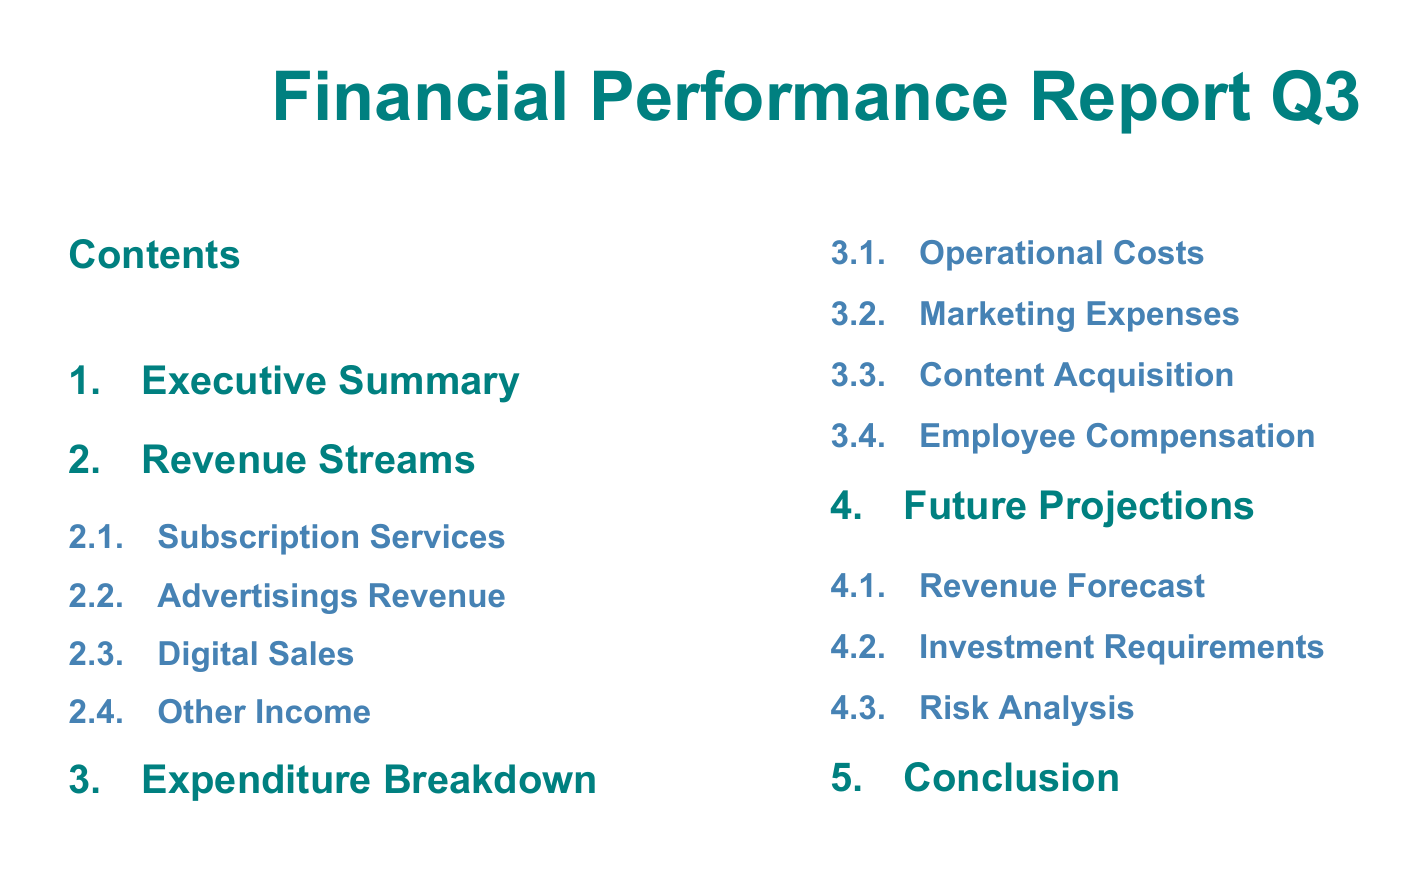What is the title of the document? The title of the document is the main heading and provides an overview of its content.
Answer: Financial Performance Report Q3 What section follows Revenue Streams? The section that follows Revenue Streams is determined by the order of sections in the table of contents.
Answer: Expenditure Breakdown How many subsections are there under Revenue Streams? The number of subsections can be counted directly from the table of contents under the Revenue Streams section.
Answer: 4 What is the first subsection under Expenditure Breakdown? The first subsection is the initial point of the Expenditure Breakdown section, indicating its primary focus.
Answer: Operational Costs What is the last section of the document? The last section signifies the conclusion and overall summary of the financial performance report.
Answer: Conclusion Which section includes risk analysis? The section that includes risk analysis can be identified by its title in the table of contents.
Answer: Future Projections What color is used for section titles? The color used for section titles is specified in the formatting of the document, indicating its visual style.
Answer: Sci-fi How are the subsections organized in the document? The subsections are organized systematically under each main section, providing a clear structure of information.
Answer: Hierarchically What theme color is used for subheadings? The theme color for subheadings is noted and indicates the document's aesthetic approach.
Answer: Subheading color 